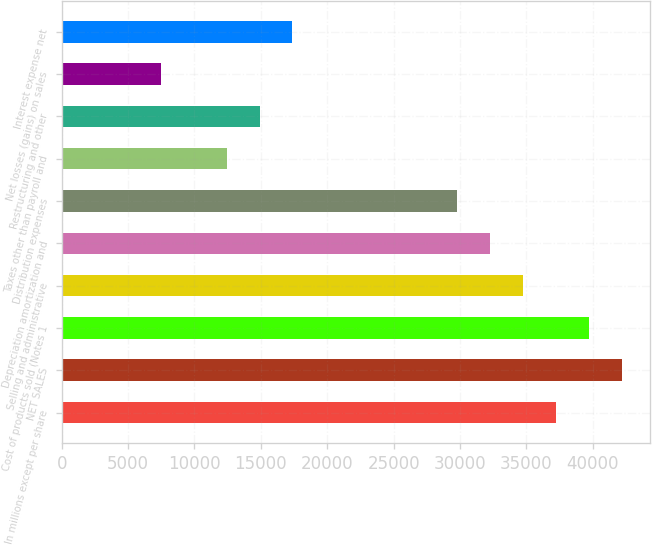<chart> <loc_0><loc_0><loc_500><loc_500><bar_chart><fcel>In millions except per share<fcel>NET SALES<fcel>Cost of products sold (Notes 1<fcel>Selling and administrative<fcel>Depreciation amortization and<fcel>Distribution expenses<fcel>Taxes other than payroll and<fcel>Restructuring and other<fcel>Net losses (gains) on sales<fcel>Interest expense net<nl><fcel>37242<fcel>42207.2<fcel>39724.6<fcel>34759.4<fcel>32276.8<fcel>29794.2<fcel>12416<fcel>14898.6<fcel>7450.8<fcel>17381.2<nl></chart> 